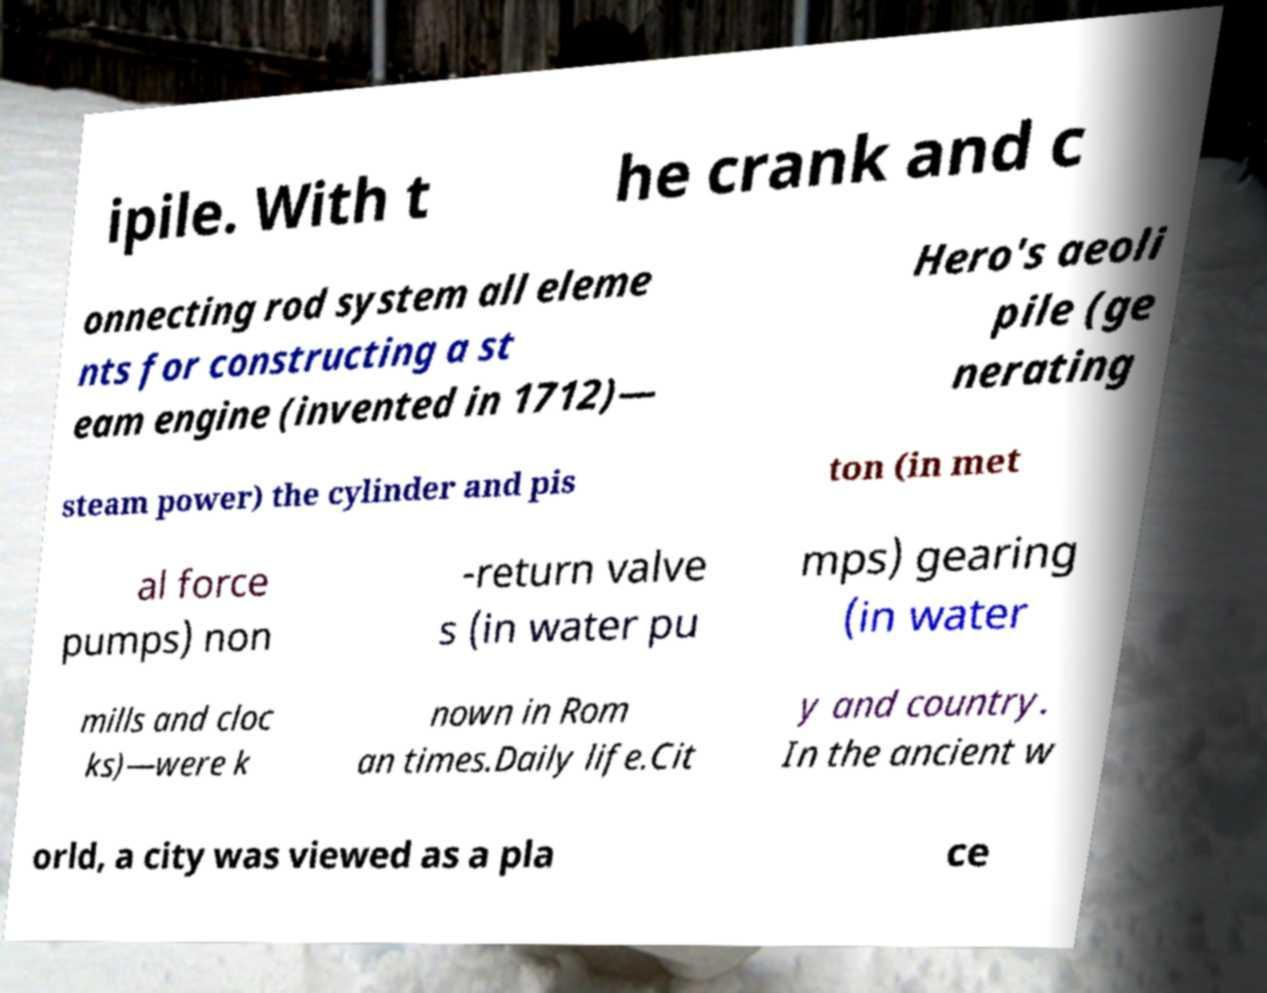Could you assist in decoding the text presented in this image and type it out clearly? ipile. With t he crank and c onnecting rod system all eleme nts for constructing a st eam engine (invented in 1712)— Hero's aeoli pile (ge nerating steam power) the cylinder and pis ton (in met al force pumps) non -return valve s (in water pu mps) gearing (in water mills and cloc ks)—were k nown in Rom an times.Daily life.Cit y and country. In the ancient w orld, a city was viewed as a pla ce 